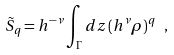<formula> <loc_0><loc_0><loc_500><loc_500>\tilde { S } _ { q } = h ^ { - \nu } \int _ { \Gamma } d z \, ( h ^ { \nu } \rho ) ^ { q } \ ,</formula> 